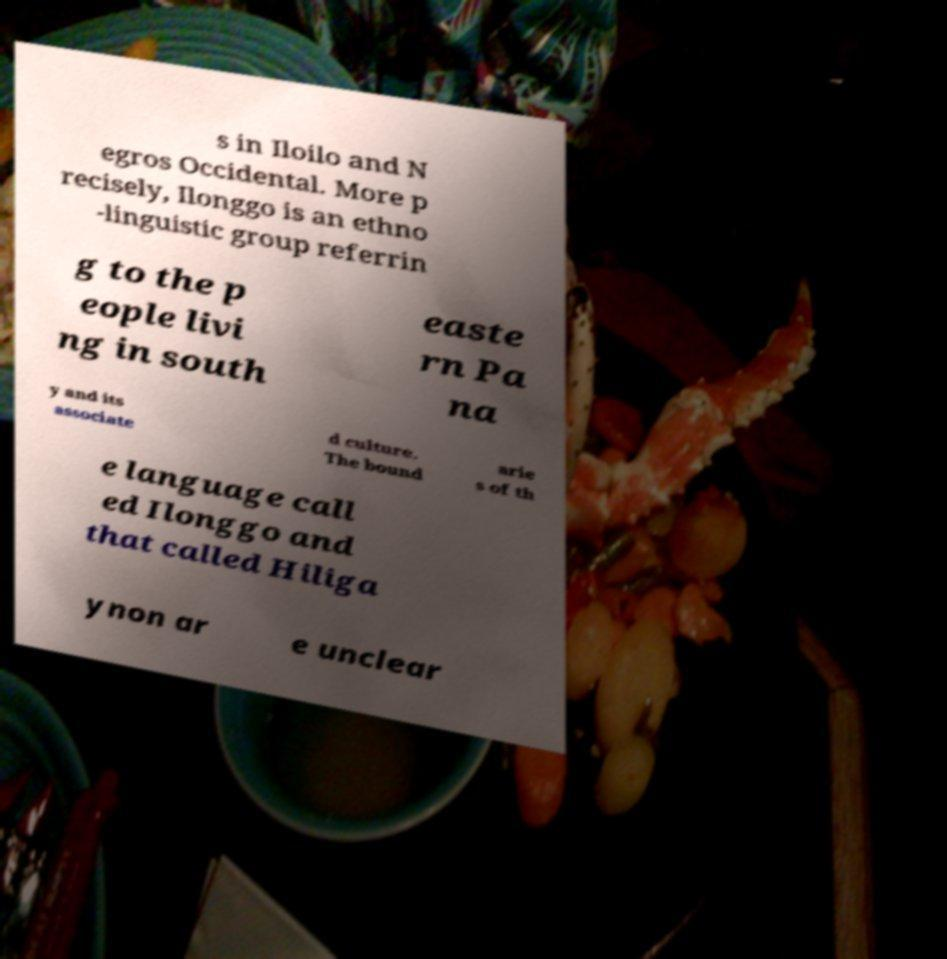I need the written content from this picture converted into text. Can you do that? s in Iloilo and N egros Occidental. More p recisely, Ilonggo is an ethno -linguistic group referrin g to the p eople livi ng in south easte rn Pa na y and its associate d culture. The bound arie s of th e language call ed Ilonggo and that called Hiliga ynon ar e unclear 